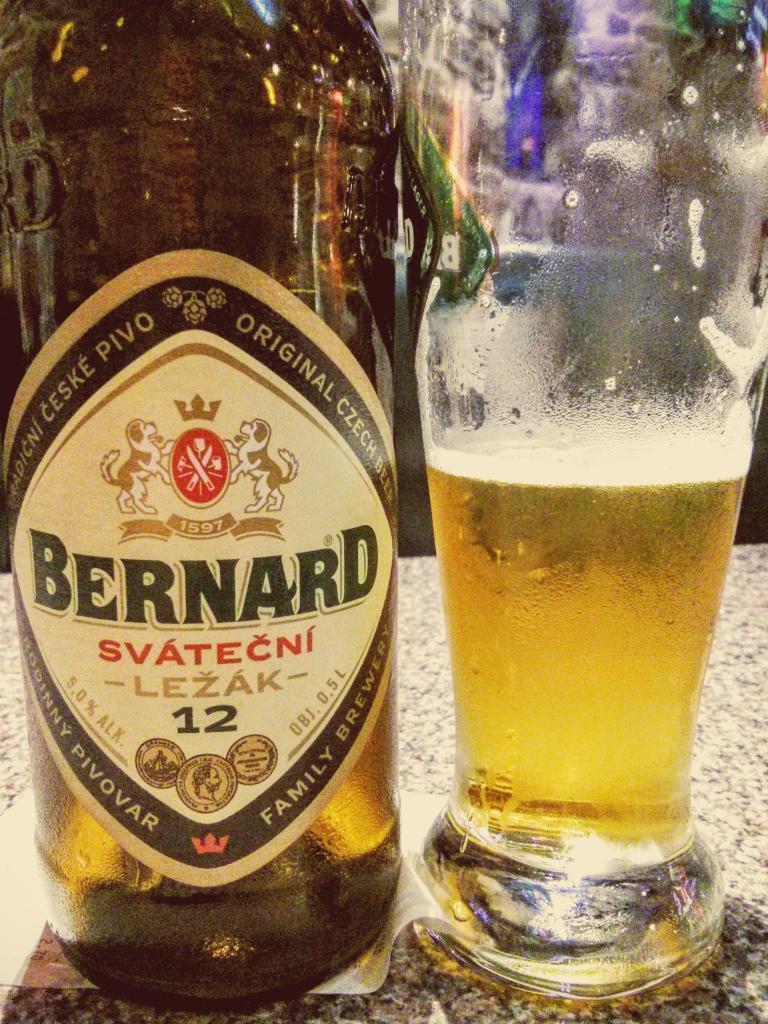Can you describe this image briefly? On this table there is a bottle and glass. This glass is filled with liquid. On this bottle there is a sticker. 